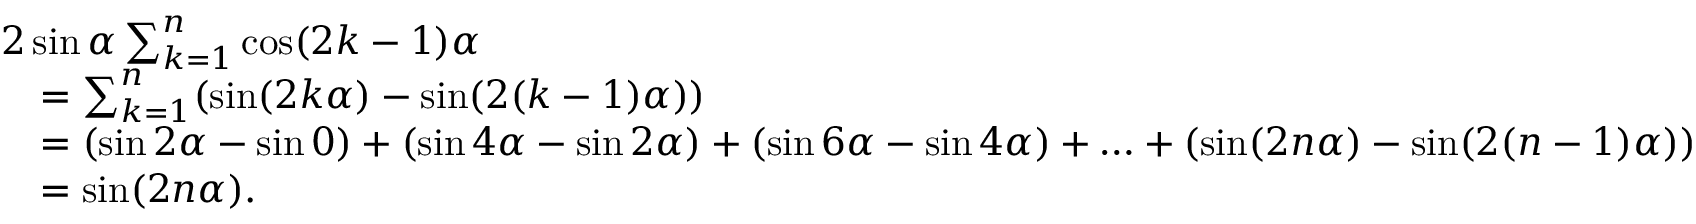<formula> <loc_0><loc_0><loc_500><loc_500>{ \begin{array} { r l } & { 2 \sin \alpha \sum _ { k = 1 } ^ { n } \cos ( 2 k - 1 ) \alpha } \\ & { \quad = \sum _ { k = 1 } ^ { n } ( \sin ( 2 k \alpha ) - \sin ( 2 ( k - 1 ) \alpha ) ) } \\ & { \quad = ( \sin 2 \alpha - \sin 0 ) + ( \sin 4 \alpha - \sin 2 \alpha ) + ( \sin 6 \alpha - \sin 4 \alpha ) + \dots + ( \sin ( 2 n \alpha ) - \sin ( 2 ( n - 1 ) \alpha ) ) } \\ & { \quad = \sin ( 2 n \alpha ) . } \end{array} }</formula> 